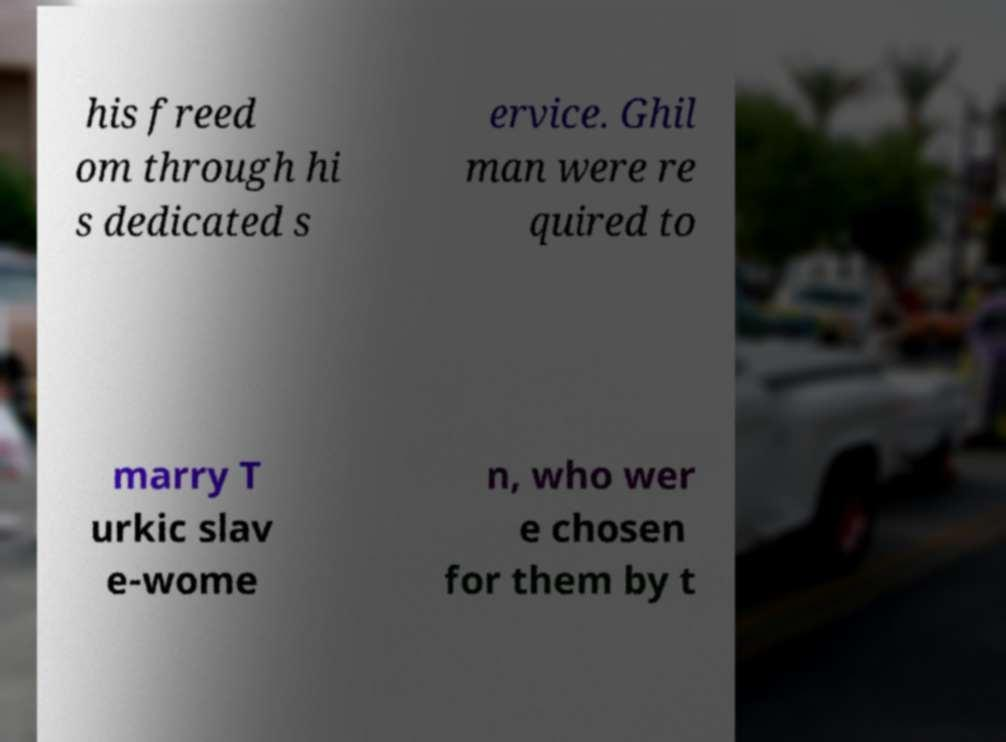Please identify and transcribe the text found in this image. his freed om through hi s dedicated s ervice. Ghil man were re quired to marry T urkic slav e-wome n, who wer e chosen for them by t 